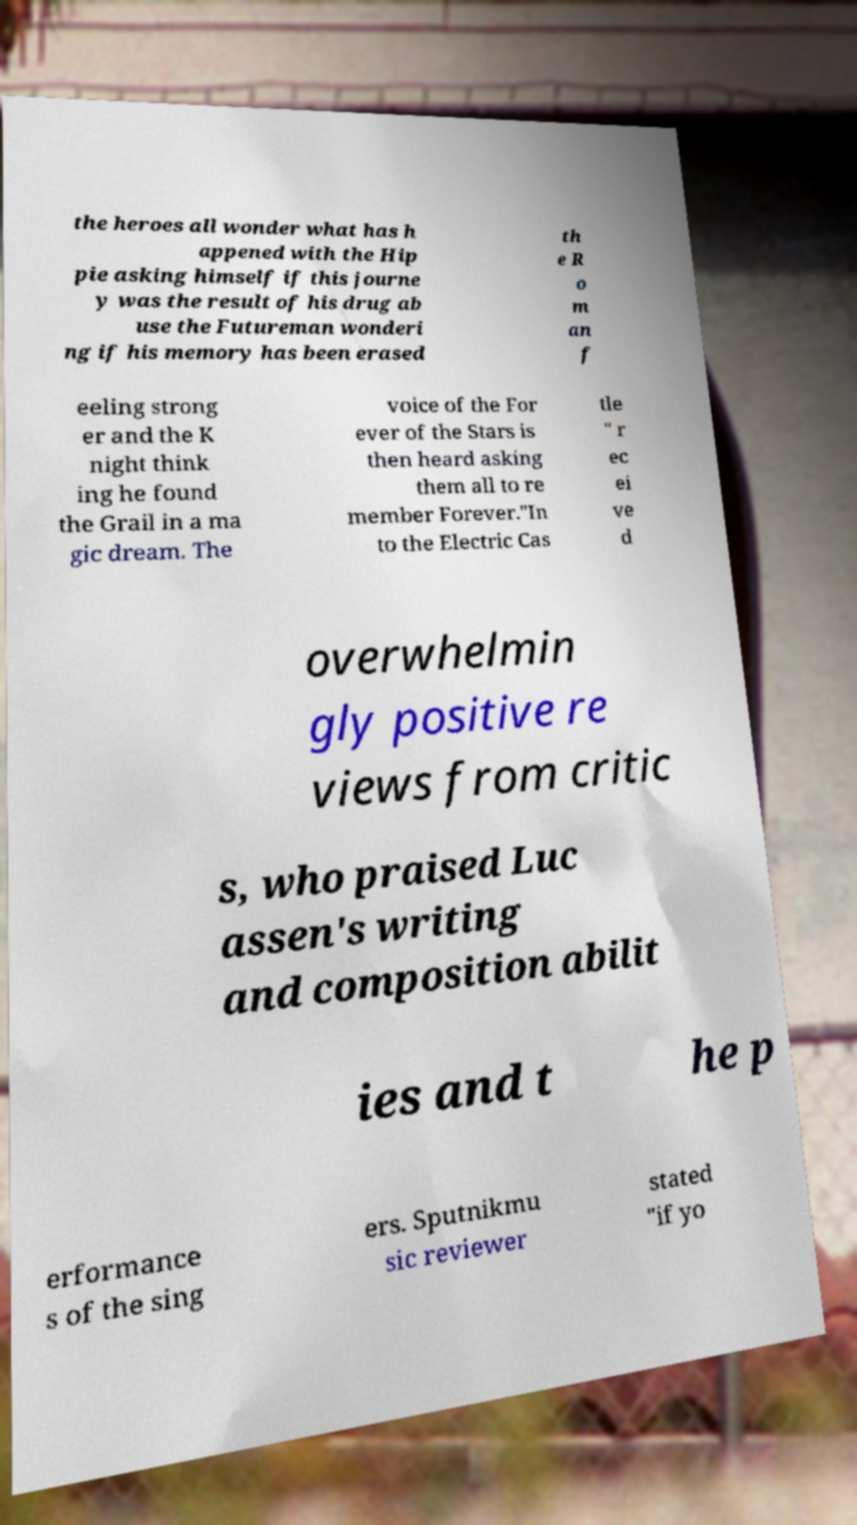Please identify and transcribe the text found in this image. the heroes all wonder what has h appened with the Hip pie asking himself if this journe y was the result of his drug ab use the Futureman wonderi ng if his memory has been erased th e R o m an f eeling strong er and the K night think ing he found the Grail in a ma gic dream. The voice of the For ever of the Stars is then heard asking them all to re member Forever."In to the Electric Cas tle " r ec ei ve d overwhelmin gly positive re views from critic s, who praised Luc assen's writing and composition abilit ies and t he p erformance s of the sing ers. Sputnikmu sic reviewer stated "if yo 